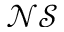<formula> <loc_0><loc_0><loc_500><loc_500>\mathcal { N S }</formula> 